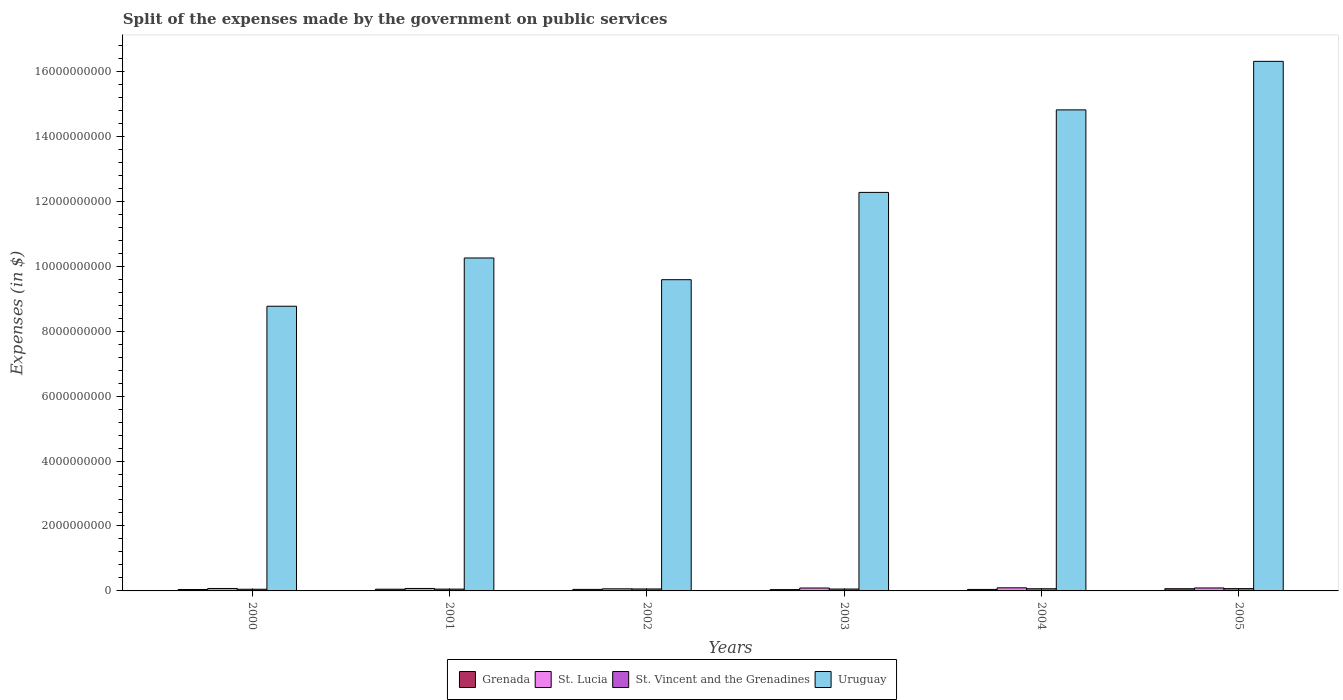How many groups of bars are there?
Provide a succinct answer. 6. Are the number of bars per tick equal to the number of legend labels?
Give a very brief answer. Yes. Are the number of bars on each tick of the X-axis equal?
Provide a short and direct response. Yes. What is the expenses made by the government on public services in St. Lucia in 2000?
Make the answer very short. 7.51e+07. Across all years, what is the maximum expenses made by the government on public services in Grenada?
Your answer should be very brief. 6.79e+07. Across all years, what is the minimum expenses made by the government on public services in St. Vincent and the Grenadines?
Offer a terse response. 5.16e+07. In which year was the expenses made by the government on public services in Uruguay maximum?
Give a very brief answer. 2005. What is the total expenses made by the government on public services in Grenada in the graph?
Your answer should be very brief. 2.98e+08. What is the difference between the expenses made by the government on public services in St. Vincent and the Grenadines in 2001 and that in 2002?
Offer a terse response. -4.90e+06. What is the difference between the expenses made by the government on public services in St. Vincent and the Grenadines in 2001 and the expenses made by the government on public services in Uruguay in 2004?
Offer a terse response. -1.48e+1. What is the average expenses made by the government on public services in St. Vincent and the Grenadines per year?
Make the answer very short. 6.04e+07. In the year 2001, what is the difference between the expenses made by the government on public services in Uruguay and expenses made by the government on public services in St. Lucia?
Your answer should be very brief. 1.02e+1. What is the ratio of the expenses made by the government on public services in St. Vincent and the Grenadines in 2000 to that in 2003?
Offer a terse response. 0.89. Is the expenses made by the government on public services in Grenada in 2000 less than that in 2002?
Your response must be concise. Yes. What is the difference between the highest and the second highest expenses made by the government on public services in St. Lucia?
Give a very brief answer. 4.50e+06. What is the difference between the highest and the lowest expenses made by the government on public services in St. Lucia?
Your response must be concise. 3.08e+07. Is the sum of the expenses made by the government on public services in Grenada in 2002 and 2005 greater than the maximum expenses made by the government on public services in St. Lucia across all years?
Your answer should be very brief. Yes. Is it the case that in every year, the sum of the expenses made by the government on public services in St. Vincent and the Grenadines and expenses made by the government on public services in St. Lucia is greater than the sum of expenses made by the government on public services in Grenada and expenses made by the government on public services in Uruguay?
Provide a short and direct response. No. What does the 3rd bar from the left in 2001 represents?
Provide a succinct answer. St. Vincent and the Grenadines. What does the 2nd bar from the right in 2002 represents?
Your response must be concise. St. Vincent and the Grenadines. Is it the case that in every year, the sum of the expenses made by the government on public services in St. Lucia and expenses made by the government on public services in Grenada is greater than the expenses made by the government on public services in Uruguay?
Provide a succinct answer. No. How many bars are there?
Provide a short and direct response. 24. Are all the bars in the graph horizontal?
Your answer should be very brief. No. Are the values on the major ticks of Y-axis written in scientific E-notation?
Ensure brevity in your answer.  No. How are the legend labels stacked?
Offer a terse response. Horizontal. What is the title of the graph?
Offer a terse response. Split of the expenses made by the government on public services. Does "Greece" appear as one of the legend labels in the graph?
Your response must be concise. No. What is the label or title of the Y-axis?
Offer a very short reply. Expenses (in $). What is the Expenses (in $) of Grenada in 2000?
Ensure brevity in your answer.  4.39e+07. What is the Expenses (in $) in St. Lucia in 2000?
Offer a terse response. 7.51e+07. What is the Expenses (in $) in St. Vincent and the Grenadines in 2000?
Provide a succinct answer. 5.16e+07. What is the Expenses (in $) in Uruguay in 2000?
Keep it short and to the point. 8.77e+09. What is the Expenses (in $) of Grenada in 2001?
Your answer should be compact. 5.26e+07. What is the Expenses (in $) in St. Lucia in 2001?
Give a very brief answer. 7.57e+07. What is the Expenses (in $) of St. Vincent and the Grenadines in 2001?
Ensure brevity in your answer.  5.57e+07. What is the Expenses (in $) in Uruguay in 2001?
Ensure brevity in your answer.  1.03e+1. What is the Expenses (in $) in Grenada in 2002?
Provide a succinct answer. 4.75e+07. What is the Expenses (in $) of St. Lucia in 2002?
Your response must be concise. 6.47e+07. What is the Expenses (in $) of St. Vincent and the Grenadines in 2002?
Keep it short and to the point. 6.06e+07. What is the Expenses (in $) in Uruguay in 2002?
Give a very brief answer. 9.58e+09. What is the Expenses (in $) in Grenada in 2003?
Provide a short and direct response. 4.05e+07. What is the Expenses (in $) in St. Lucia in 2003?
Your answer should be compact. 8.95e+07. What is the Expenses (in $) of St. Vincent and the Grenadines in 2003?
Provide a succinct answer. 5.79e+07. What is the Expenses (in $) in Uruguay in 2003?
Offer a terse response. 1.23e+1. What is the Expenses (in $) in Grenada in 2004?
Provide a short and direct response. 4.61e+07. What is the Expenses (in $) in St. Lucia in 2004?
Your response must be concise. 9.55e+07. What is the Expenses (in $) in St. Vincent and the Grenadines in 2004?
Your answer should be very brief. 6.66e+07. What is the Expenses (in $) of Uruguay in 2004?
Offer a very short reply. 1.48e+1. What is the Expenses (in $) in Grenada in 2005?
Provide a short and direct response. 6.79e+07. What is the Expenses (in $) of St. Lucia in 2005?
Offer a very short reply. 9.10e+07. What is the Expenses (in $) in St. Vincent and the Grenadines in 2005?
Give a very brief answer. 7.03e+07. What is the Expenses (in $) of Uruguay in 2005?
Your answer should be compact. 1.63e+1. Across all years, what is the maximum Expenses (in $) in Grenada?
Provide a succinct answer. 6.79e+07. Across all years, what is the maximum Expenses (in $) of St. Lucia?
Your answer should be compact. 9.55e+07. Across all years, what is the maximum Expenses (in $) of St. Vincent and the Grenadines?
Offer a very short reply. 7.03e+07. Across all years, what is the maximum Expenses (in $) of Uruguay?
Offer a terse response. 1.63e+1. Across all years, what is the minimum Expenses (in $) of Grenada?
Your answer should be very brief. 4.05e+07. Across all years, what is the minimum Expenses (in $) in St. Lucia?
Provide a succinct answer. 6.47e+07. Across all years, what is the minimum Expenses (in $) of St. Vincent and the Grenadines?
Make the answer very short. 5.16e+07. Across all years, what is the minimum Expenses (in $) in Uruguay?
Your response must be concise. 8.77e+09. What is the total Expenses (in $) of Grenada in the graph?
Make the answer very short. 2.98e+08. What is the total Expenses (in $) of St. Lucia in the graph?
Your response must be concise. 4.92e+08. What is the total Expenses (in $) in St. Vincent and the Grenadines in the graph?
Keep it short and to the point. 3.63e+08. What is the total Expenses (in $) in Uruguay in the graph?
Provide a succinct answer. 7.20e+1. What is the difference between the Expenses (in $) of Grenada in 2000 and that in 2001?
Provide a succinct answer. -8.70e+06. What is the difference between the Expenses (in $) in St. Lucia in 2000 and that in 2001?
Provide a short and direct response. -6.00e+05. What is the difference between the Expenses (in $) of St. Vincent and the Grenadines in 2000 and that in 2001?
Give a very brief answer. -4.10e+06. What is the difference between the Expenses (in $) of Uruguay in 2000 and that in 2001?
Provide a short and direct response. -1.49e+09. What is the difference between the Expenses (in $) of Grenada in 2000 and that in 2002?
Offer a terse response. -3.60e+06. What is the difference between the Expenses (in $) of St. Lucia in 2000 and that in 2002?
Give a very brief answer. 1.04e+07. What is the difference between the Expenses (in $) in St. Vincent and the Grenadines in 2000 and that in 2002?
Offer a very short reply. -9.00e+06. What is the difference between the Expenses (in $) of Uruguay in 2000 and that in 2002?
Ensure brevity in your answer.  -8.17e+08. What is the difference between the Expenses (in $) in Grenada in 2000 and that in 2003?
Offer a terse response. 3.40e+06. What is the difference between the Expenses (in $) in St. Lucia in 2000 and that in 2003?
Make the answer very short. -1.44e+07. What is the difference between the Expenses (in $) of St. Vincent and the Grenadines in 2000 and that in 2003?
Provide a short and direct response. -6.30e+06. What is the difference between the Expenses (in $) in Uruguay in 2000 and that in 2003?
Make the answer very short. -3.50e+09. What is the difference between the Expenses (in $) of Grenada in 2000 and that in 2004?
Keep it short and to the point. -2.20e+06. What is the difference between the Expenses (in $) in St. Lucia in 2000 and that in 2004?
Offer a terse response. -2.04e+07. What is the difference between the Expenses (in $) of St. Vincent and the Grenadines in 2000 and that in 2004?
Provide a succinct answer. -1.50e+07. What is the difference between the Expenses (in $) of Uruguay in 2000 and that in 2004?
Make the answer very short. -6.05e+09. What is the difference between the Expenses (in $) in Grenada in 2000 and that in 2005?
Give a very brief answer. -2.40e+07. What is the difference between the Expenses (in $) in St. Lucia in 2000 and that in 2005?
Your answer should be compact. -1.59e+07. What is the difference between the Expenses (in $) of St. Vincent and the Grenadines in 2000 and that in 2005?
Your answer should be very brief. -1.87e+07. What is the difference between the Expenses (in $) of Uruguay in 2000 and that in 2005?
Give a very brief answer. -7.54e+09. What is the difference between the Expenses (in $) of Grenada in 2001 and that in 2002?
Offer a very short reply. 5.10e+06. What is the difference between the Expenses (in $) in St. Lucia in 2001 and that in 2002?
Offer a very short reply. 1.10e+07. What is the difference between the Expenses (in $) of St. Vincent and the Grenadines in 2001 and that in 2002?
Give a very brief answer. -4.90e+06. What is the difference between the Expenses (in $) in Uruguay in 2001 and that in 2002?
Ensure brevity in your answer.  6.69e+08. What is the difference between the Expenses (in $) in Grenada in 2001 and that in 2003?
Give a very brief answer. 1.21e+07. What is the difference between the Expenses (in $) in St. Lucia in 2001 and that in 2003?
Make the answer very short. -1.38e+07. What is the difference between the Expenses (in $) of St. Vincent and the Grenadines in 2001 and that in 2003?
Offer a very short reply. -2.20e+06. What is the difference between the Expenses (in $) of Uruguay in 2001 and that in 2003?
Ensure brevity in your answer.  -2.02e+09. What is the difference between the Expenses (in $) in Grenada in 2001 and that in 2004?
Ensure brevity in your answer.  6.50e+06. What is the difference between the Expenses (in $) of St. Lucia in 2001 and that in 2004?
Provide a short and direct response. -1.98e+07. What is the difference between the Expenses (in $) of St. Vincent and the Grenadines in 2001 and that in 2004?
Provide a succinct answer. -1.09e+07. What is the difference between the Expenses (in $) of Uruguay in 2001 and that in 2004?
Your response must be concise. -4.56e+09. What is the difference between the Expenses (in $) of Grenada in 2001 and that in 2005?
Give a very brief answer. -1.53e+07. What is the difference between the Expenses (in $) of St. Lucia in 2001 and that in 2005?
Offer a very short reply. -1.53e+07. What is the difference between the Expenses (in $) of St. Vincent and the Grenadines in 2001 and that in 2005?
Your answer should be very brief. -1.46e+07. What is the difference between the Expenses (in $) in Uruguay in 2001 and that in 2005?
Make the answer very short. -6.05e+09. What is the difference between the Expenses (in $) of St. Lucia in 2002 and that in 2003?
Offer a very short reply. -2.48e+07. What is the difference between the Expenses (in $) of St. Vincent and the Grenadines in 2002 and that in 2003?
Your response must be concise. 2.70e+06. What is the difference between the Expenses (in $) in Uruguay in 2002 and that in 2003?
Make the answer very short. -2.69e+09. What is the difference between the Expenses (in $) in Grenada in 2002 and that in 2004?
Your answer should be very brief. 1.40e+06. What is the difference between the Expenses (in $) of St. Lucia in 2002 and that in 2004?
Make the answer very short. -3.08e+07. What is the difference between the Expenses (in $) in St. Vincent and the Grenadines in 2002 and that in 2004?
Give a very brief answer. -6.00e+06. What is the difference between the Expenses (in $) in Uruguay in 2002 and that in 2004?
Your answer should be compact. -5.23e+09. What is the difference between the Expenses (in $) of Grenada in 2002 and that in 2005?
Your answer should be very brief. -2.04e+07. What is the difference between the Expenses (in $) of St. Lucia in 2002 and that in 2005?
Offer a terse response. -2.63e+07. What is the difference between the Expenses (in $) of St. Vincent and the Grenadines in 2002 and that in 2005?
Offer a terse response. -9.70e+06. What is the difference between the Expenses (in $) of Uruguay in 2002 and that in 2005?
Make the answer very short. -6.72e+09. What is the difference between the Expenses (in $) in Grenada in 2003 and that in 2004?
Offer a terse response. -5.60e+06. What is the difference between the Expenses (in $) of St. Lucia in 2003 and that in 2004?
Ensure brevity in your answer.  -6.00e+06. What is the difference between the Expenses (in $) in St. Vincent and the Grenadines in 2003 and that in 2004?
Provide a short and direct response. -8.70e+06. What is the difference between the Expenses (in $) of Uruguay in 2003 and that in 2004?
Keep it short and to the point. -2.54e+09. What is the difference between the Expenses (in $) in Grenada in 2003 and that in 2005?
Keep it short and to the point. -2.74e+07. What is the difference between the Expenses (in $) in St. Lucia in 2003 and that in 2005?
Offer a very short reply. -1.50e+06. What is the difference between the Expenses (in $) in St. Vincent and the Grenadines in 2003 and that in 2005?
Your response must be concise. -1.24e+07. What is the difference between the Expenses (in $) in Uruguay in 2003 and that in 2005?
Offer a very short reply. -4.04e+09. What is the difference between the Expenses (in $) in Grenada in 2004 and that in 2005?
Make the answer very short. -2.18e+07. What is the difference between the Expenses (in $) of St. Lucia in 2004 and that in 2005?
Make the answer very short. 4.50e+06. What is the difference between the Expenses (in $) of St. Vincent and the Grenadines in 2004 and that in 2005?
Your answer should be compact. -3.70e+06. What is the difference between the Expenses (in $) of Uruguay in 2004 and that in 2005?
Offer a very short reply. -1.49e+09. What is the difference between the Expenses (in $) of Grenada in 2000 and the Expenses (in $) of St. Lucia in 2001?
Offer a very short reply. -3.18e+07. What is the difference between the Expenses (in $) in Grenada in 2000 and the Expenses (in $) in St. Vincent and the Grenadines in 2001?
Keep it short and to the point. -1.18e+07. What is the difference between the Expenses (in $) of Grenada in 2000 and the Expenses (in $) of Uruguay in 2001?
Make the answer very short. -1.02e+1. What is the difference between the Expenses (in $) in St. Lucia in 2000 and the Expenses (in $) in St. Vincent and the Grenadines in 2001?
Keep it short and to the point. 1.94e+07. What is the difference between the Expenses (in $) of St. Lucia in 2000 and the Expenses (in $) of Uruguay in 2001?
Keep it short and to the point. -1.02e+1. What is the difference between the Expenses (in $) of St. Vincent and the Grenadines in 2000 and the Expenses (in $) of Uruguay in 2001?
Provide a succinct answer. -1.02e+1. What is the difference between the Expenses (in $) of Grenada in 2000 and the Expenses (in $) of St. Lucia in 2002?
Keep it short and to the point. -2.08e+07. What is the difference between the Expenses (in $) of Grenada in 2000 and the Expenses (in $) of St. Vincent and the Grenadines in 2002?
Keep it short and to the point. -1.67e+07. What is the difference between the Expenses (in $) of Grenada in 2000 and the Expenses (in $) of Uruguay in 2002?
Your answer should be compact. -9.54e+09. What is the difference between the Expenses (in $) of St. Lucia in 2000 and the Expenses (in $) of St. Vincent and the Grenadines in 2002?
Your response must be concise. 1.45e+07. What is the difference between the Expenses (in $) in St. Lucia in 2000 and the Expenses (in $) in Uruguay in 2002?
Your answer should be very brief. -9.51e+09. What is the difference between the Expenses (in $) in St. Vincent and the Grenadines in 2000 and the Expenses (in $) in Uruguay in 2002?
Give a very brief answer. -9.53e+09. What is the difference between the Expenses (in $) in Grenada in 2000 and the Expenses (in $) in St. Lucia in 2003?
Provide a succinct answer. -4.56e+07. What is the difference between the Expenses (in $) of Grenada in 2000 and the Expenses (in $) of St. Vincent and the Grenadines in 2003?
Your answer should be compact. -1.40e+07. What is the difference between the Expenses (in $) in Grenada in 2000 and the Expenses (in $) in Uruguay in 2003?
Provide a succinct answer. -1.22e+1. What is the difference between the Expenses (in $) in St. Lucia in 2000 and the Expenses (in $) in St. Vincent and the Grenadines in 2003?
Give a very brief answer. 1.72e+07. What is the difference between the Expenses (in $) of St. Lucia in 2000 and the Expenses (in $) of Uruguay in 2003?
Offer a very short reply. -1.22e+1. What is the difference between the Expenses (in $) in St. Vincent and the Grenadines in 2000 and the Expenses (in $) in Uruguay in 2003?
Make the answer very short. -1.22e+1. What is the difference between the Expenses (in $) of Grenada in 2000 and the Expenses (in $) of St. Lucia in 2004?
Give a very brief answer. -5.16e+07. What is the difference between the Expenses (in $) in Grenada in 2000 and the Expenses (in $) in St. Vincent and the Grenadines in 2004?
Ensure brevity in your answer.  -2.27e+07. What is the difference between the Expenses (in $) of Grenada in 2000 and the Expenses (in $) of Uruguay in 2004?
Offer a very short reply. -1.48e+1. What is the difference between the Expenses (in $) of St. Lucia in 2000 and the Expenses (in $) of St. Vincent and the Grenadines in 2004?
Offer a terse response. 8.50e+06. What is the difference between the Expenses (in $) in St. Lucia in 2000 and the Expenses (in $) in Uruguay in 2004?
Your answer should be compact. -1.47e+1. What is the difference between the Expenses (in $) in St. Vincent and the Grenadines in 2000 and the Expenses (in $) in Uruguay in 2004?
Give a very brief answer. -1.48e+1. What is the difference between the Expenses (in $) in Grenada in 2000 and the Expenses (in $) in St. Lucia in 2005?
Your answer should be very brief. -4.71e+07. What is the difference between the Expenses (in $) in Grenada in 2000 and the Expenses (in $) in St. Vincent and the Grenadines in 2005?
Your response must be concise. -2.64e+07. What is the difference between the Expenses (in $) of Grenada in 2000 and the Expenses (in $) of Uruguay in 2005?
Ensure brevity in your answer.  -1.63e+1. What is the difference between the Expenses (in $) in St. Lucia in 2000 and the Expenses (in $) in St. Vincent and the Grenadines in 2005?
Ensure brevity in your answer.  4.80e+06. What is the difference between the Expenses (in $) in St. Lucia in 2000 and the Expenses (in $) in Uruguay in 2005?
Keep it short and to the point. -1.62e+1. What is the difference between the Expenses (in $) in St. Vincent and the Grenadines in 2000 and the Expenses (in $) in Uruguay in 2005?
Your answer should be very brief. -1.63e+1. What is the difference between the Expenses (in $) of Grenada in 2001 and the Expenses (in $) of St. Lucia in 2002?
Make the answer very short. -1.21e+07. What is the difference between the Expenses (in $) of Grenada in 2001 and the Expenses (in $) of St. Vincent and the Grenadines in 2002?
Keep it short and to the point. -8.00e+06. What is the difference between the Expenses (in $) in Grenada in 2001 and the Expenses (in $) in Uruguay in 2002?
Ensure brevity in your answer.  -9.53e+09. What is the difference between the Expenses (in $) in St. Lucia in 2001 and the Expenses (in $) in St. Vincent and the Grenadines in 2002?
Make the answer very short. 1.51e+07. What is the difference between the Expenses (in $) of St. Lucia in 2001 and the Expenses (in $) of Uruguay in 2002?
Provide a short and direct response. -9.51e+09. What is the difference between the Expenses (in $) of St. Vincent and the Grenadines in 2001 and the Expenses (in $) of Uruguay in 2002?
Your answer should be compact. -9.53e+09. What is the difference between the Expenses (in $) in Grenada in 2001 and the Expenses (in $) in St. Lucia in 2003?
Provide a short and direct response. -3.69e+07. What is the difference between the Expenses (in $) in Grenada in 2001 and the Expenses (in $) in St. Vincent and the Grenadines in 2003?
Provide a short and direct response. -5.30e+06. What is the difference between the Expenses (in $) of Grenada in 2001 and the Expenses (in $) of Uruguay in 2003?
Your answer should be very brief. -1.22e+1. What is the difference between the Expenses (in $) of St. Lucia in 2001 and the Expenses (in $) of St. Vincent and the Grenadines in 2003?
Your answer should be compact. 1.78e+07. What is the difference between the Expenses (in $) of St. Lucia in 2001 and the Expenses (in $) of Uruguay in 2003?
Make the answer very short. -1.22e+1. What is the difference between the Expenses (in $) in St. Vincent and the Grenadines in 2001 and the Expenses (in $) in Uruguay in 2003?
Your answer should be compact. -1.22e+1. What is the difference between the Expenses (in $) in Grenada in 2001 and the Expenses (in $) in St. Lucia in 2004?
Provide a succinct answer. -4.29e+07. What is the difference between the Expenses (in $) of Grenada in 2001 and the Expenses (in $) of St. Vincent and the Grenadines in 2004?
Offer a terse response. -1.40e+07. What is the difference between the Expenses (in $) in Grenada in 2001 and the Expenses (in $) in Uruguay in 2004?
Offer a very short reply. -1.48e+1. What is the difference between the Expenses (in $) in St. Lucia in 2001 and the Expenses (in $) in St. Vincent and the Grenadines in 2004?
Provide a succinct answer. 9.10e+06. What is the difference between the Expenses (in $) in St. Lucia in 2001 and the Expenses (in $) in Uruguay in 2004?
Offer a very short reply. -1.47e+1. What is the difference between the Expenses (in $) of St. Vincent and the Grenadines in 2001 and the Expenses (in $) of Uruguay in 2004?
Give a very brief answer. -1.48e+1. What is the difference between the Expenses (in $) in Grenada in 2001 and the Expenses (in $) in St. Lucia in 2005?
Make the answer very short. -3.84e+07. What is the difference between the Expenses (in $) of Grenada in 2001 and the Expenses (in $) of St. Vincent and the Grenadines in 2005?
Provide a short and direct response. -1.77e+07. What is the difference between the Expenses (in $) of Grenada in 2001 and the Expenses (in $) of Uruguay in 2005?
Your answer should be compact. -1.63e+1. What is the difference between the Expenses (in $) of St. Lucia in 2001 and the Expenses (in $) of St. Vincent and the Grenadines in 2005?
Give a very brief answer. 5.40e+06. What is the difference between the Expenses (in $) of St. Lucia in 2001 and the Expenses (in $) of Uruguay in 2005?
Offer a very short reply. -1.62e+1. What is the difference between the Expenses (in $) of St. Vincent and the Grenadines in 2001 and the Expenses (in $) of Uruguay in 2005?
Ensure brevity in your answer.  -1.63e+1. What is the difference between the Expenses (in $) in Grenada in 2002 and the Expenses (in $) in St. Lucia in 2003?
Your answer should be compact. -4.20e+07. What is the difference between the Expenses (in $) in Grenada in 2002 and the Expenses (in $) in St. Vincent and the Grenadines in 2003?
Give a very brief answer. -1.04e+07. What is the difference between the Expenses (in $) in Grenada in 2002 and the Expenses (in $) in Uruguay in 2003?
Ensure brevity in your answer.  -1.22e+1. What is the difference between the Expenses (in $) of St. Lucia in 2002 and the Expenses (in $) of St. Vincent and the Grenadines in 2003?
Give a very brief answer. 6.80e+06. What is the difference between the Expenses (in $) of St. Lucia in 2002 and the Expenses (in $) of Uruguay in 2003?
Provide a short and direct response. -1.22e+1. What is the difference between the Expenses (in $) in St. Vincent and the Grenadines in 2002 and the Expenses (in $) in Uruguay in 2003?
Provide a succinct answer. -1.22e+1. What is the difference between the Expenses (in $) of Grenada in 2002 and the Expenses (in $) of St. Lucia in 2004?
Offer a terse response. -4.80e+07. What is the difference between the Expenses (in $) in Grenada in 2002 and the Expenses (in $) in St. Vincent and the Grenadines in 2004?
Offer a terse response. -1.91e+07. What is the difference between the Expenses (in $) of Grenada in 2002 and the Expenses (in $) of Uruguay in 2004?
Ensure brevity in your answer.  -1.48e+1. What is the difference between the Expenses (in $) of St. Lucia in 2002 and the Expenses (in $) of St. Vincent and the Grenadines in 2004?
Offer a very short reply. -1.90e+06. What is the difference between the Expenses (in $) in St. Lucia in 2002 and the Expenses (in $) in Uruguay in 2004?
Provide a short and direct response. -1.47e+1. What is the difference between the Expenses (in $) of St. Vincent and the Grenadines in 2002 and the Expenses (in $) of Uruguay in 2004?
Provide a short and direct response. -1.48e+1. What is the difference between the Expenses (in $) in Grenada in 2002 and the Expenses (in $) in St. Lucia in 2005?
Your response must be concise. -4.35e+07. What is the difference between the Expenses (in $) in Grenada in 2002 and the Expenses (in $) in St. Vincent and the Grenadines in 2005?
Give a very brief answer. -2.28e+07. What is the difference between the Expenses (in $) of Grenada in 2002 and the Expenses (in $) of Uruguay in 2005?
Give a very brief answer. -1.63e+1. What is the difference between the Expenses (in $) in St. Lucia in 2002 and the Expenses (in $) in St. Vincent and the Grenadines in 2005?
Ensure brevity in your answer.  -5.60e+06. What is the difference between the Expenses (in $) in St. Lucia in 2002 and the Expenses (in $) in Uruguay in 2005?
Make the answer very short. -1.62e+1. What is the difference between the Expenses (in $) in St. Vincent and the Grenadines in 2002 and the Expenses (in $) in Uruguay in 2005?
Your response must be concise. -1.62e+1. What is the difference between the Expenses (in $) in Grenada in 2003 and the Expenses (in $) in St. Lucia in 2004?
Your answer should be compact. -5.50e+07. What is the difference between the Expenses (in $) in Grenada in 2003 and the Expenses (in $) in St. Vincent and the Grenadines in 2004?
Ensure brevity in your answer.  -2.61e+07. What is the difference between the Expenses (in $) of Grenada in 2003 and the Expenses (in $) of Uruguay in 2004?
Keep it short and to the point. -1.48e+1. What is the difference between the Expenses (in $) of St. Lucia in 2003 and the Expenses (in $) of St. Vincent and the Grenadines in 2004?
Your response must be concise. 2.29e+07. What is the difference between the Expenses (in $) in St. Lucia in 2003 and the Expenses (in $) in Uruguay in 2004?
Offer a very short reply. -1.47e+1. What is the difference between the Expenses (in $) in St. Vincent and the Grenadines in 2003 and the Expenses (in $) in Uruguay in 2004?
Your response must be concise. -1.48e+1. What is the difference between the Expenses (in $) of Grenada in 2003 and the Expenses (in $) of St. Lucia in 2005?
Provide a succinct answer. -5.05e+07. What is the difference between the Expenses (in $) of Grenada in 2003 and the Expenses (in $) of St. Vincent and the Grenadines in 2005?
Your answer should be compact. -2.98e+07. What is the difference between the Expenses (in $) in Grenada in 2003 and the Expenses (in $) in Uruguay in 2005?
Your response must be concise. -1.63e+1. What is the difference between the Expenses (in $) of St. Lucia in 2003 and the Expenses (in $) of St. Vincent and the Grenadines in 2005?
Your answer should be compact. 1.92e+07. What is the difference between the Expenses (in $) of St. Lucia in 2003 and the Expenses (in $) of Uruguay in 2005?
Offer a very short reply. -1.62e+1. What is the difference between the Expenses (in $) in St. Vincent and the Grenadines in 2003 and the Expenses (in $) in Uruguay in 2005?
Your answer should be very brief. -1.62e+1. What is the difference between the Expenses (in $) in Grenada in 2004 and the Expenses (in $) in St. Lucia in 2005?
Give a very brief answer. -4.49e+07. What is the difference between the Expenses (in $) of Grenada in 2004 and the Expenses (in $) of St. Vincent and the Grenadines in 2005?
Make the answer very short. -2.42e+07. What is the difference between the Expenses (in $) of Grenada in 2004 and the Expenses (in $) of Uruguay in 2005?
Make the answer very short. -1.63e+1. What is the difference between the Expenses (in $) of St. Lucia in 2004 and the Expenses (in $) of St. Vincent and the Grenadines in 2005?
Ensure brevity in your answer.  2.52e+07. What is the difference between the Expenses (in $) of St. Lucia in 2004 and the Expenses (in $) of Uruguay in 2005?
Your response must be concise. -1.62e+1. What is the difference between the Expenses (in $) of St. Vincent and the Grenadines in 2004 and the Expenses (in $) of Uruguay in 2005?
Offer a terse response. -1.62e+1. What is the average Expenses (in $) in Grenada per year?
Make the answer very short. 4.98e+07. What is the average Expenses (in $) of St. Lucia per year?
Ensure brevity in your answer.  8.19e+07. What is the average Expenses (in $) of St. Vincent and the Grenadines per year?
Make the answer very short. 6.04e+07. What is the average Expenses (in $) of Uruguay per year?
Your answer should be very brief. 1.20e+1. In the year 2000, what is the difference between the Expenses (in $) of Grenada and Expenses (in $) of St. Lucia?
Your response must be concise. -3.12e+07. In the year 2000, what is the difference between the Expenses (in $) of Grenada and Expenses (in $) of St. Vincent and the Grenadines?
Provide a succinct answer. -7.70e+06. In the year 2000, what is the difference between the Expenses (in $) of Grenada and Expenses (in $) of Uruguay?
Your response must be concise. -8.72e+09. In the year 2000, what is the difference between the Expenses (in $) in St. Lucia and Expenses (in $) in St. Vincent and the Grenadines?
Make the answer very short. 2.35e+07. In the year 2000, what is the difference between the Expenses (in $) in St. Lucia and Expenses (in $) in Uruguay?
Your answer should be very brief. -8.69e+09. In the year 2000, what is the difference between the Expenses (in $) in St. Vincent and the Grenadines and Expenses (in $) in Uruguay?
Provide a succinct answer. -8.71e+09. In the year 2001, what is the difference between the Expenses (in $) in Grenada and Expenses (in $) in St. Lucia?
Ensure brevity in your answer.  -2.31e+07. In the year 2001, what is the difference between the Expenses (in $) of Grenada and Expenses (in $) of St. Vincent and the Grenadines?
Ensure brevity in your answer.  -3.10e+06. In the year 2001, what is the difference between the Expenses (in $) of Grenada and Expenses (in $) of Uruguay?
Give a very brief answer. -1.02e+1. In the year 2001, what is the difference between the Expenses (in $) in St. Lucia and Expenses (in $) in St. Vincent and the Grenadines?
Your response must be concise. 2.00e+07. In the year 2001, what is the difference between the Expenses (in $) in St. Lucia and Expenses (in $) in Uruguay?
Your answer should be very brief. -1.02e+1. In the year 2001, what is the difference between the Expenses (in $) in St. Vincent and the Grenadines and Expenses (in $) in Uruguay?
Offer a very short reply. -1.02e+1. In the year 2002, what is the difference between the Expenses (in $) of Grenada and Expenses (in $) of St. Lucia?
Provide a succinct answer. -1.72e+07. In the year 2002, what is the difference between the Expenses (in $) in Grenada and Expenses (in $) in St. Vincent and the Grenadines?
Make the answer very short. -1.31e+07. In the year 2002, what is the difference between the Expenses (in $) of Grenada and Expenses (in $) of Uruguay?
Ensure brevity in your answer.  -9.54e+09. In the year 2002, what is the difference between the Expenses (in $) in St. Lucia and Expenses (in $) in St. Vincent and the Grenadines?
Offer a very short reply. 4.10e+06. In the year 2002, what is the difference between the Expenses (in $) in St. Lucia and Expenses (in $) in Uruguay?
Offer a very short reply. -9.52e+09. In the year 2002, what is the difference between the Expenses (in $) in St. Vincent and the Grenadines and Expenses (in $) in Uruguay?
Provide a short and direct response. -9.52e+09. In the year 2003, what is the difference between the Expenses (in $) in Grenada and Expenses (in $) in St. Lucia?
Provide a succinct answer. -4.90e+07. In the year 2003, what is the difference between the Expenses (in $) of Grenada and Expenses (in $) of St. Vincent and the Grenadines?
Keep it short and to the point. -1.74e+07. In the year 2003, what is the difference between the Expenses (in $) in Grenada and Expenses (in $) in Uruguay?
Offer a terse response. -1.22e+1. In the year 2003, what is the difference between the Expenses (in $) in St. Lucia and Expenses (in $) in St. Vincent and the Grenadines?
Your response must be concise. 3.16e+07. In the year 2003, what is the difference between the Expenses (in $) in St. Lucia and Expenses (in $) in Uruguay?
Your response must be concise. -1.22e+1. In the year 2003, what is the difference between the Expenses (in $) in St. Vincent and the Grenadines and Expenses (in $) in Uruguay?
Your answer should be compact. -1.22e+1. In the year 2004, what is the difference between the Expenses (in $) of Grenada and Expenses (in $) of St. Lucia?
Your response must be concise. -4.94e+07. In the year 2004, what is the difference between the Expenses (in $) in Grenada and Expenses (in $) in St. Vincent and the Grenadines?
Your answer should be very brief. -2.05e+07. In the year 2004, what is the difference between the Expenses (in $) in Grenada and Expenses (in $) in Uruguay?
Your response must be concise. -1.48e+1. In the year 2004, what is the difference between the Expenses (in $) of St. Lucia and Expenses (in $) of St. Vincent and the Grenadines?
Offer a very short reply. 2.89e+07. In the year 2004, what is the difference between the Expenses (in $) in St. Lucia and Expenses (in $) in Uruguay?
Offer a very short reply. -1.47e+1. In the year 2004, what is the difference between the Expenses (in $) of St. Vincent and the Grenadines and Expenses (in $) of Uruguay?
Keep it short and to the point. -1.47e+1. In the year 2005, what is the difference between the Expenses (in $) of Grenada and Expenses (in $) of St. Lucia?
Make the answer very short. -2.31e+07. In the year 2005, what is the difference between the Expenses (in $) in Grenada and Expenses (in $) in St. Vincent and the Grenadines?
Ensure brevity in your answer.  -2.40e+06. In the year 2005, what is the difference between the Expenses (in $) of Grenada and Expenses (in $) of Uruguay?
Offer a very short reply. -1.62e+1. In the year 2005, what is the difference between the Expenses (in $) in St. Lucia and Expenses (in $) in St. Vincent and the Grenadines?
Offer a terse response. 2.07e+07. In the year 2005, what is the difference between the Expenses (in $) in St. Lucia and Expenses (in $) in Uruguay?
Give a very brief answer. -1.62e+1. In the year 2005, what is the difference between the Expenses (in $) of St. Vincent and the Grenadines and Expenses (in $) of Uruguay?
Ensure brevity in your answer.  -1.62e+1. What is the ratio of the Expenses (in $) of Grenada in 2000 to that in 2001?
Offer a terse response. 0.83. What is the ratio of the Expenses (in $) in St. Lucia in 2000 to that in 2001?
Provide a succinct answer. 0.99. What is the ratio of the Expenses (in $) in St. Vincent and the Grenadines in 2000 to that in 2001?
Make the answer very short. 0.93. What is the ratio of the Expenses (in $) of Uruguay in 2000 to that in 2001?
Your answer should be compact. 0.86. What is the ratio of the Expenses (in $) of Grenada in 2000 to that in 2002?
Provide a short and direct response. 0.92. What is the ratio of the Expenses (in $) of St. Lucia in 2000 to that in 2002?
Ensure brevity in your answer.  1.16. What is the ratio of the Expenses (in $) in St. Vincent and the Grenadines in 2000 to that in 2002?
Provide a succinct answer. 0.85. What is the ratio of the Expenses (in $) in Uruguay in 2000 to that in 2002?
Offer a very short reply. 0.91. What is the ratio of the Expenses (in $) in Grenada in 2000 to that in 2003?
Your response must be concise. 1.08. What is the ratio of the Expenses (in $) in St. Lucia in 2000 to that in 2003?
Give a very brief answer. 0.84. What is the ratio of the Expenses (in $) in St. Vincent and the Grenadines in 2000 to that in 2003?
Make the answer very short. 0.89. What is the ratio of the Expenses (in $) in Uruguay in 2000 to that in 2003?
Offer a terse response. 0.71. What is the ratio of the Expenses (in $) in Grenada in 2000 to that in 2004?
Your answer should be very brief. 0.95. What is the ratio of the Expenses (in $) in St. Lucia in 2000 to that in 2004?
Provide a short and direct response. 0.79. What is the ratio of the Expenses (in $) of St. Vincent and the Grenadines in 2000 to that in 2004?
Give a very brief answer. 0.77. What is the ratio of the Expenses (in $) of Uruguay in 2000 to that in 2004?
Keep it short and to the point. 0.59. What is the ratio of the Expenses (in $) in Grenada in 2000 to that in 2005?
Your response must be concise. 0.65. What is the ratio of the Expenses (in $) of St. Lucia in 2000 to that in 2005?
Provide a succinct answer. 0.83. What is the ratio of the Expenses (in $) of St. Vincent and the Grenadines in 2000 to that in 2005?
Your answer should be very brief. 0.73. What is the ratio of the Expenses (in $) of Uruguay in 2000 to that in 2005?
Make the answer very short. 0.54. What is the ratio of the Expenses (in $) in Grenada in 2001 to that in 2002?
Your answer should be compact. 1.11. What is the ratio of the Expenses (in $) in St. Lucia in 2001 to that in 2002?
Ensure brevity in your answer.  1.17. What is the ratio of the Expenses (in $) of St. Vincent and the Grenadines in 2001 to that in 2002?
Keep it short and to the point. 0.92. What is the ratio of the Expenses (in $) in Uruguay in 2001 to that in 2002?
Offer a terse response. 1.07. What is the ratio of the Expenses (in $) of Grenada in 2001 to that in 2003?
Offer a very short reply. 1.3. What is the ratio of the Expenses (in $) of St. Lucia in 2001 to that in 2003?
Give a very brief answer. 0.85. What is the ratio of the Expenses (in $) of St. Vincent and the Grenadines in 2001 to that in 2003?
Your response must be concise. 0.96. What is the ratio of the Expenses (in $) in Uruguay in 2001 to that in 2003?
Give a very brief answer. 0.84. What is the ratio of the Expenses (in $) in Grenada in 2001 to that in 2004?
Keep it short and to the point. 1.14. What is the ratio of the Expenses (in $) in St. Lucia in 2001 to that in 2004?
Keep it short and to the point. 0.79. What is the ratio of the Expenses (in $) in St. Vincent and the Grenadines in 2001 to that in 2004?
Make the answer very short. 0.84. What is the ratio of the Expenses (in $) of Uruguay in 2001 to that in 2004?
Your response must be concise. 0.69. What is the ratio of the Expenses (in $) in Grenada in 2001 to that in 2005?
Offer a very short reply. 0.77. What is the ratio of the Expenses (in $) of St. Lucia in 2001 to that in 2005?
Keep it short and to the point. 0.83. What is the ratio of the Expenses (in $) of St. Vincent and the Grenadines in 2001 to that in 2005?
Offer a terse response. 0.79. What is the ratio of the Expenses (in $) of Uruguay in 2001 to that in 2005?
Give a very brief answer. 0.63. What is the ratio of the Expenses (in $) in Grenada in 2002 to that in 2003?
Provide a short and direct response. 1.17. What is the ratio of the Expenses (in $) in St. Lucia in 2002 to that in 2003?
Give a very brief answer. 0.72. What is the ratio of the Expenses (in $) of St. Vincent and the Grenadines in 2002 to that in 2003?
Your response must be concise. 1.05. What is the ratio of the Expenses (in $) in Uruguay in 2002 to that in 2003?
Offer a terse response. 0.78. What is the ratio of the Expenses (in $) of Grenada in 2002 to that in 2004?
Keep it short and to the point. 1.03. What is the ratio of the Expenses (in $) of St. Lucia in 2002 to that in 2004?
Your answer should be very brief. 0.68. What is the ratio of the Expenses (in $) of St. Vincent and the Grenadines in 2002 to that in 2004?
Offer a terse response. 0.91. What is the ratio of the Expenses (in $) of Uruguay in 2002 to that in 2004?
Ensure brevity in your answer.  0.65. What is the ratio of the Expenses (in $) of Grenada in 2002 to that in 2005?
Provide a short and direct response. 0.7. What is the ratio of the Expenses (in $) of St. Lucia in 2002 to that in 2005?
Provide a short and direct response. 0.71. What is the ratio of the Expenses (in $) in St. Vincent and the Grenadines in 2002 to that in 2005?
Offer a terse response. 0.86. What is the ratio of the Expenses (in $) of Uruguay in 2002 to that in 2005?
Offer a very short reply. 0.59. What is the ratio of the Expenses (in $) of Grenada in 2003 to that in 2004?
Ensure brevity in your answer.  0.88. What is the ratio of the Expenses (in $) in St. Lucia in 2003 to that in 2004?
Provide a short and direct response. 0.94. What is the ratio of the Expenses (in $) of St. Vincent and the Grenadines in 2003 to that in 2004?
Provide a succinct answer. 0.87. What is the ratio of the Expenses (in $) of Uruguay in 2003 to that in 2004?
Offer a terse response. 0.83. What is the ratio of the Expenses (in $) in Grenada in 2003 to that in 2005?
Make the answer very short. 0.6. What is the ratio of the Expenses (in $) of St. Lucia in 2003 to that in 2005?
Your response must be concise. 0.98. What is the ratio of the Expenses (in $) in St. Vincent and the Grenadines in 2003 to that in 2005?
Your answer should be very brief. 0.82. What is the ratio of the Expenses (in $) in Uruguay in 2003 to that in 2005?
Your answer should be very brief. 0.75. What is the ratio of the Expenses (in $) in Grenada in 2004 to that in 2005?
Give a very brief answer. 0.68. What is the ratio of the Expenses (in $) of St. Lucia in 2004 to that in 2005?
Ensure brevity in your answer.  1.05. What is the ratio of the Expenses (in $) of St. Vincent and the Grenadines in 2004 to that in 2005?
Your response must be concise. 0.95. What is the ratio of the Expenses (in $) of Uruguay in 2004 to that in 2005?
Ensure brevity in your answer.  0.91. What is the difference between the highest and the second highest Expenses (in $) of Grenada?
Provide a short and direct response. 1.53e+07. What is the difference between the highest and the second highest Expenses (in $) of St. Lucia?
Your response must be concise. 4.50e+06. What is the difference between the highest and the second highest Expenses (in $) in St. Vincent and the Grenadines?
Give a very brief answer. 3.70e+06. What is the difference between the highest and the second highest Expenses (in $) in Uruguay?
Your response must be concise. 1.49e+09. What is the difference between the highest and the lowest Expenses (in $) of Grenada?
Ensure brevity in your answer.  2.74e+07. What is the difference between the highest and the lowest Expenses (in $) in St. Lucia?
Provide a short and direct response. 3.08e+07. What is the difference between the highest and the lowest Expenses (in $) in St. Vincent and the Grenadines?
Make the answer very short. 1.87e+07. What is the difference between the highest and the lowest Expenses (in $) in Uruguay?
Ensure brevity in your answer.  7.54e+09. 